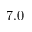Convert formula to latex. <formula><loc_0><loc_0><loc_500><loc_500>7 . 0</formula> 